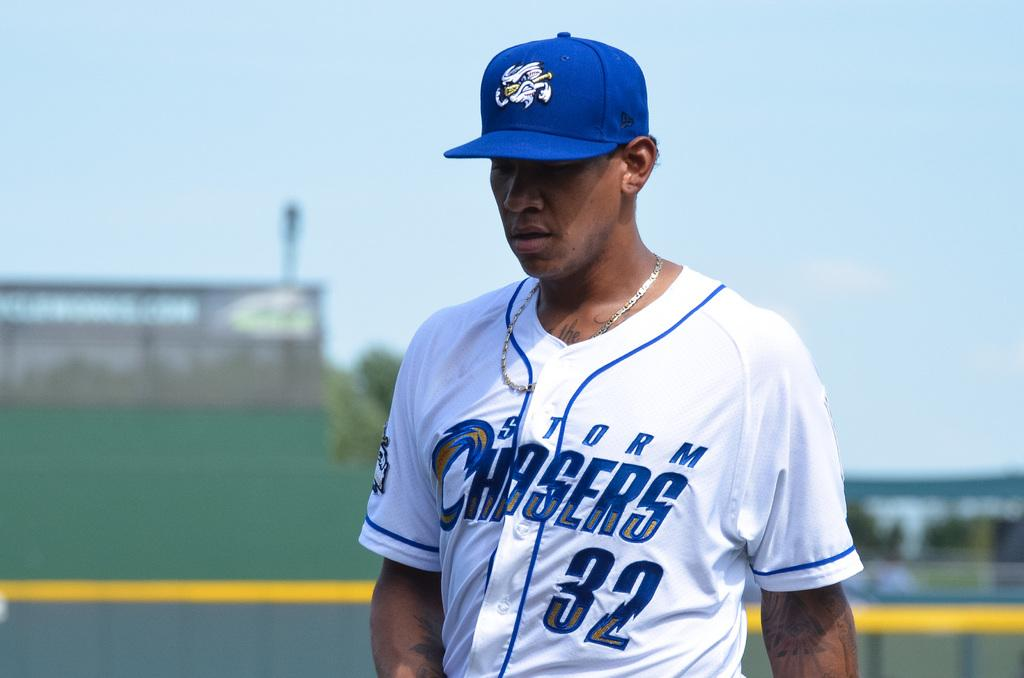<image>
Describe the image concisely. A baseball player wearing a blue and white uniform with Storm Chasers written on the shirt. 